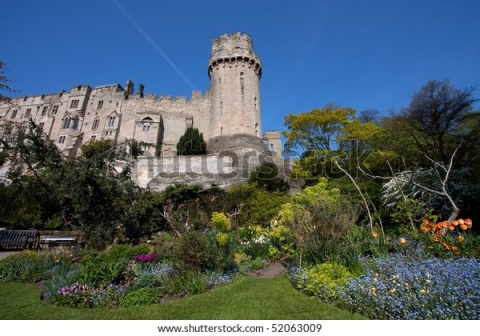Explain the visual content of the image in great detail. The image presents an enchanting view of a majestic castle surrounded by a splendid garden. The castle is primarily constructed from gray stone, featuring a tall, cylindrical tower on the left side adorned with numerous windows that add to its historic charm. The tower stands out with its round structure at the top, further enhancing the castle's imposing presence.

Beneath the castle, a lush garden bursts with vibrant colors, showcasing a variety of flowers including striking orange tulips and delicate blue forget-me-nots. The garden is meticulously landscaped with green shrubs that provide a calming backdrop to the vivid floral display. The overall layout of the garden is thoughtfully designed, contributing to the tranquil and inviting ambiance of the scene.

In the foreground, a quaint wooden bench invites visitors to sit and admire the beauty of their surroundings. The bench, positioned close to the viewer, adds a personal touch to the scene, suggesting a place of rest and reflection. Above, a clear blue sky stretches wide, casting a serene light over the entire landscape. The crispness of the sky complements the vividness of the garden and the majestic stature of the castle, creating a harmonious and picturesque setting. 